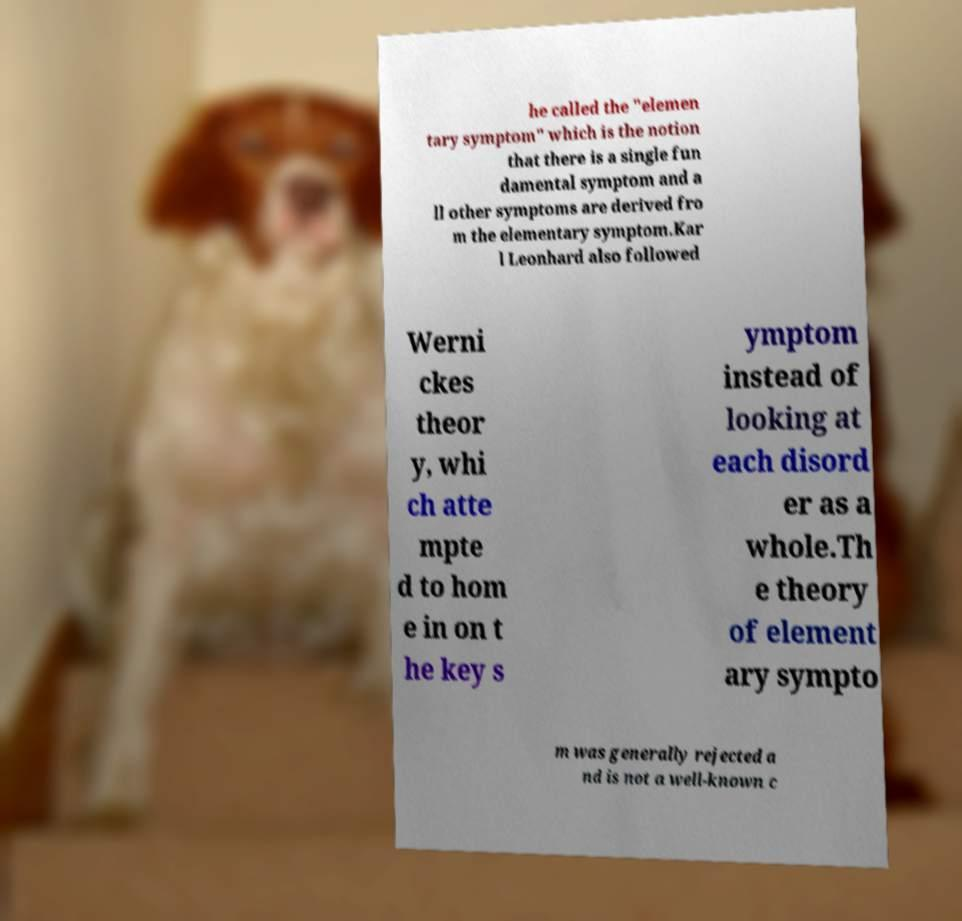I need the written content from this picture converted into text. Can you do that? he called the "elemen tary symptom" which is the notion that there is a single fun damental symptom and a ll other symptoms are derived fro m the elementary symptom.Kar l Leonhard also followed Werni ckes theor y, whi ch atte mpte d to hom e in on t he key s ymptom instead of looking at each disord er as a whole.Th e theory of element ary sympto m was generally rejected a nd is not a well-known c 